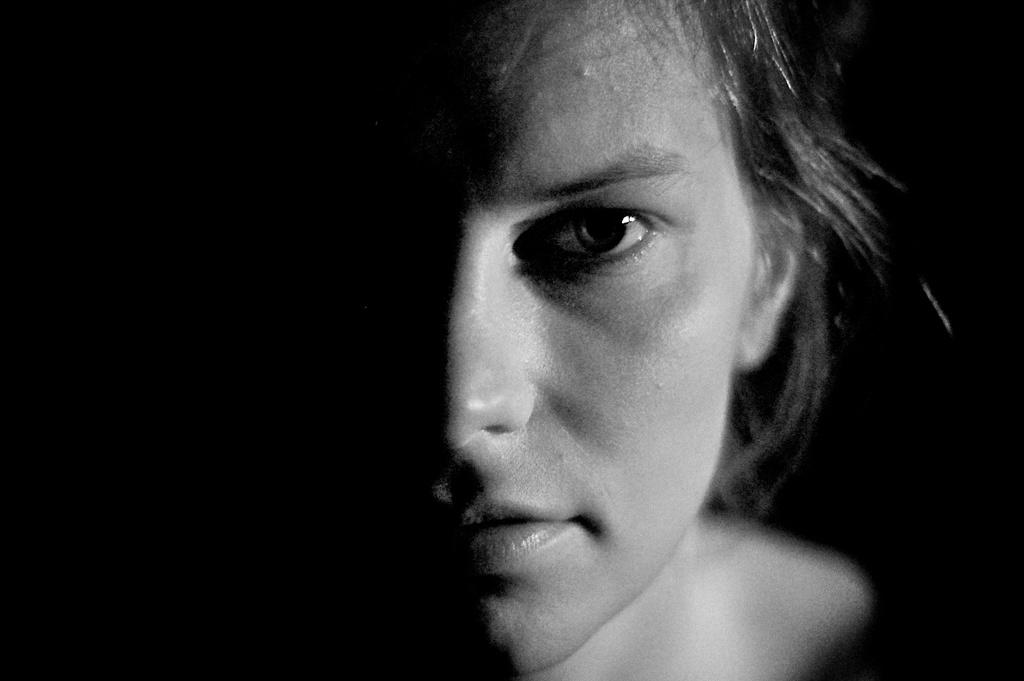What is the color scheme of the image? The image is black and white. What is the main subject of the image? There is a face of a person in the image. What color is the background of the image? The background of the image is black. Can you see any birds in the image? There are no birds visible in the image. What type of thrill can be experienced by the person in the image? The image does not provide any information about the person's emotions or experiences, so it cannot be determined if they are experiencing any thrill. 